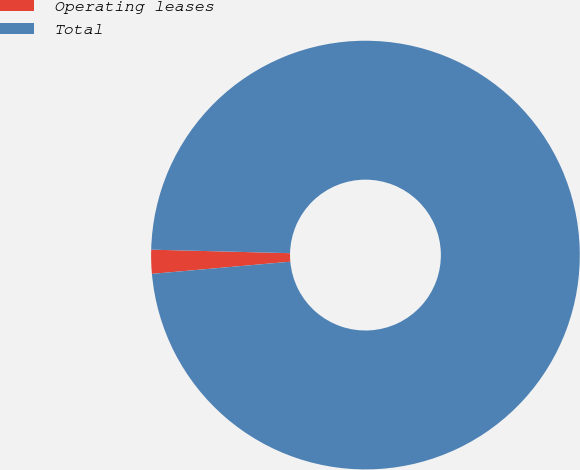Convert chart to OTSL. <chart><loc_0><loc_0><loc_500><loc_500><pie_chart><fcel>Operating leases<fcel>Total<nl><fcel>1.8%<fcel>98.2%<nl></chart> 